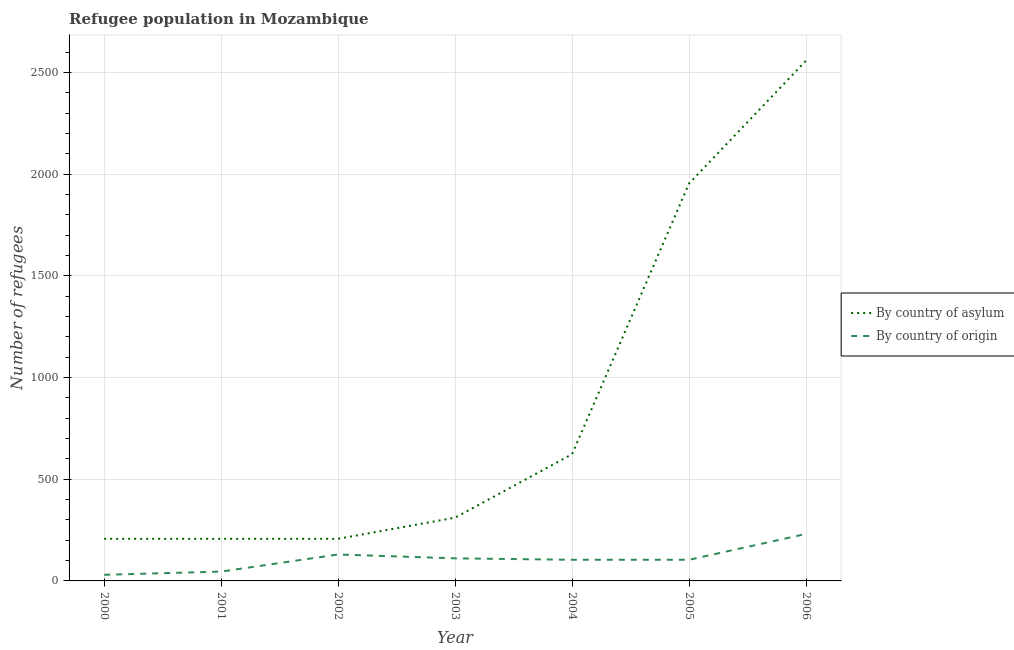How many different coloured lines are there?
Keep it short and to the point. 2. What is the number of refugees by country of asylum in 2005?
Your response must be concise. 1954. Across all years, what is the maximum number of refugees by country of asylum?
Provide a short and direct response. 2558. Across all years, what is the minimum number of refugees by country of asylum?
Make the answer very short. 207. What is the total number of refugees by country of origin in the graph?
Your answer should be compact. 756. What is the difference between the number of refugees by country of asylum in 2000 and that in 2006?
Your answer should be compact. -2351. What is the difference between the number of refugees by country of asylum in 2005 and the number of refugees by country of origin in 2002?
Your response must be concise. 1824. What is the average number of refugees by country of asylum per year?
Your response must be concise. 866.71. In the year 2002, what is the difference between the number of refugees by country of origin and number of refugees by country of asylum?
Offer a very short reply. -77. In how many years, is the number of refugees by country of origin greater than 1000?
Your answer should be compact. 0. What is the ratio of the number of refugees by country of origin in 2002 to that in 2006?
Provide a short and direct response. 0.56. Is the number of refugees by country of origin in 2002 less than that in 2004?
Provide a succinct answer. No. What is the difference between the highest and the second highest number of refugees by country of origin?
Make the answer very short. 101. What is the difference between the highest and the lowest number of refugees by country of asylum?
Offer a very short reply. 2351. Does the number of refugees by country of origin monotonically increase over the years?
Ensure brevity in your answer.  No. Is the number of refugees by country of origin strictly less than the number of refugees by country of asylum over the years?
Make the answer very short. Yes. How many lines are there?
Make the answer very short. 2. What is the difference between two consecutive major ticks on the Y-axis?
Your answer should be compact. 500. Where does the legend appear in the graph?
Provide a succinct answer. Center right. What is the title of the graph?
Give a very brief answer. Refugee population in Mozambique. What is the label or title of the X-axis?
Your response must be concise. Year. What is the label or title of the Y-axis?
Your answer should be very brief. Number of refugees. What is the Number of refugees of By country of asylum in 2000?
Offer a terse response. 207. What is the Number of refugees of By country of asylum in 2001?
Provide a succinct answer. 207. What is the Number of refugees in By country of asylum in 2002?
Ensure brevity in your answer.  207. What is the Number of refugees of By country of origin in 2002?
Provide a succinct answer. 130. What is the Number of refugees in By country of asylum in 2003?
Provide a short and direct response. 311. What is the Number of refugees in By country of origin in 2003?
Keep it short and to the point. 111. What is the Number of refugees in By country of asylum in 2004?
Make the answer very short. 623. What is the Number of refugees of By country of origin in 2004?
Offer a terse response. 104. What is the Number of refugees of By country of asylum in 2005?
Make the answer very short. 1954. What is the Number of refugees in By country of origin in 2005?
Provide a succinct answer. 104. What is the Number of refugees of By country of asylum in 2006?
Make the answer very short. 2558. What is the Number of refugees in By country of origin in 2006?
Keep it short and to the point. 231. Across all years, what is the maximum Number of refugees of By country of asylum?
Provide a short and direct response. 2558. Across all years, what is the maximum Number of refugees of By country of origin?
Make the answer very short. 231. Across all years, what is the minimum Number of refugees in By country of asylum?
Offer a terse response. 207. What is the total Number of refugees of By country of asylum in the graph?
Ensure brevity in your answer.  6067. What is the total Number of refugees in By country of origin in the graph?
Provide a short and direct response. 756. What is the difference between the Number of refugees in By country of origin in 2000 and that in 2001?
Give a very brief answer. -16. What is the difference between the Number of refugees of By country of asylum in 2000 and that in 2002?
Your answer should be compact. 0. What is the difference between the Number of refugees of By country of origin in 2000 and that in 2002?
Your answer should be compact. -100. What is the difference between the Number of refugees in By country of asylum in 2000 and that in 2003?
Your answer should be compact. -104. What is the difference between the Number of refugees in By country of origin in 2000 and that in 2003?
Your answer should be very brief. -81. What is the difference between the Number of refugees in By country of asylum in 2000 and that in 2004?
Provide a succinct answer. -416. What is the difference between the Number of refugees in By country of origin in 2000 and that in 2004?
Keep it short and to the point. -74. What is the difference between the Number of refugees in By country of asylum in 2000 and that in 2005?
Offer a terse response. -1747. What is the difference between the Number of refugees of By country of origin in 2000 and that in 2005?
Offer a terse response. -74. What is the difference between the Number of refugees of By country of asylum in 2000 and that in 2006?
Ensure brevity in your answer.  -2351. What is the difference between the Number of refugees in By country of origin in 2000 and that in 2006?
Ensure brevity in your answer.  -201. What is the difference between the Number of refugees of By country of origin in 2001 and that in 2002?
Offer a very short reply. -84. What is the difference between the Number of refugees of By country of asylum in 2001 and that in 2003?
Provide a short and direct response. -104. What is the difference between the Number of refugees in By country of origin in 2001 and that in 2003?
Provide a succinct answer. -65. What is the difference between the Number of refugees in By country of asylum in 2001 and that in 2004?
Your answer should be very brief. -416. What is the difference between the Number of refugees of By country of origin in 2001 and that in 2004?
Offer a very short reply. -58. What is the difference between the Number of refugees in By country of asylum in 2001 and that in 2005?
Ensure brevity in your answer.  -1747. What is the difference between the Number of refugees of By country of origin in 2001 and that in 2005?
Give a very brief answer. -58. What is the difference between the Number of refugees in By country of asylum in 2001 and that in 2006?
Your answer should be compact. -2351. What is the difference between the Number of refugees in By country of origin in 2001 and that in 2006?
Offer a terse response. -185. What is the difference between the Number of refugees in By country of asylum in 2002 and that in 2003?
Offer a very short reply. -104. What is the difference between the Number of refugees in By country of asylum in 2002 and that in 2004?
Ensure brevity in your answer.  -416. What is the difference between the Number of refugees in By country of asylum in 2002 and that in 2005?
Give a very brief answer. -1747. What is the difference between the Number of refugees in By country of origin in 2002 and that in 2005?
Your response must be concise. 26. What is the difference between the Number of refugees of By country of asylum in 2002 and that in 2006?
Provide a succinct answer. -2351. What is the difference between the Number of refugees of By country of origin in 2002 and that in 2006?
Ensure brevity in your answer.  -101. What is the difference between the Number of refugees of By country of asylum in 2003 and that in 2004?
Make the answer very short. -312. What is the difference between the Number of refugees of By country of origin in 2003 and that in 2004?
Your answer should be compact. 7. What is the difference between the Number of refugees of By country of asylum in 2003 and that in 2005?
Your answer should be compact. -1643. What is the difference between the Number of refugees of By country of origin in 2003 and that in 2005?
Make the answer very short. 7. What is the difference between the Number of refugees of By country of asylum in 2003 and that in 2006?
Offer a very short reply. -2247. What is the difference between the Number of refugees in By country of origin in 2003 and that in 2006?
Give a very brief answer. -120. What is the difference between the Number of refugees of By country of asylum in 2004 and that in 2005?
Provide a short and direct response. -1331. What is the difference between the Number of refugees of By country of origin in 2004 and that in 2005?
Ensure brevity in your answer.  0. What is the difference between the Number of refugees in By country of asylum in 2004 and that in 2006?
Make the answer very short. -1935. What is the difference between the Number of refugees of By country of origin in 2004 and that in 2006?
Your response must be concise. -127. What is the difference between the Number of refugees of By country of asylum in 2005 and that in 2006?
Provide a succinct answer. -604. What is the difference between the Number of refugees in By country of origin in 2005 and that in 2006?
Your answer should be very brief. -127. What is the difference between the Number of refugees in By country of asylum in 2000 and the Number of refugees in By country of origin in 2001?
Provide a short and direct response. 161. What is the difference between the Number of refugees of By country of asylum in 2000 and the Number of refugees of By country of origin in 2002?
Ensure brevity in your answer.  77. What is the difference between the Number of refugees of By country of asylum in 2000 and the Number of refugees of By country of origin in 2003?
Your response must be concise. 96. What is the difference between the Number of refugees of By country of asylum in 2000 and the Number of refugees of By country of origin in 2004?
Your answer should be very brief. 103. What is the difference between the Number of refugees in By country of asylum in 2000 and the Number of refugees in By country of origin in 2005?
Keep it short and to the point. 103. What is the difference between the Number of refugees in By country of asylum in 2000 and the Number of refugees in By country of origin in 2006?
Your response must be concise. -24. What is the difference between the Number of refugees in By country of asylum in 2001 and the Number of refugees in By country of origin in 2003?
Offer a terse response. 96. What is the difference between the Number of refugees in By country of asylum in 2001 and the Number of refugees in By country of origin in 2004?
Your answer should be compact. 103. What is the difference between the Number of refugees of By country of asylum in 2001 and the Number of refugees of By country of origin in 2005?
Provide a succinct answer. 103. What is the difference between the Number of refugees in By country of asylum in 2002 and the Number of refugees in By country of origin in 2003?
Your answer should be compact. 96. What is the difference between the Number of refugees of By country of asylum in 2002 and the Number of refugees of By country of origin in 2004?
Your answer should be very brief. 103. What is the difference between the Number of refugees of By country of asylum in 2002 and the Number of refugees of By country of origin in 2005?
Ensure brevity in your answer.  103. What is the difference between the Number of refugees of By country of asylum in 2003 and the Number of refugees of By country of origin in 2004?
Give a very brief answer. 207. What is the difference between the Number of refugees in By country of asylum in 2003 and the Number of refugees in By country of origin in 2005?
Give a very brief answer. 207. What is the difference between the Number of refugees of By country of asylum in 2003 and the Number of refugees of By country of origin in 2006?
Ensure brevity in your answer.  80. What is the difference between the Number of refugees in By country of asylum in 2004 and the Number of refugees in By country of origin in 2005?
Offer a very short reply. 519. What is the difference between the Number of refugees in By country of asylum in 2004 and the Number of refugees in By country of origin in 2006?
Give a very brief answer. 392. What is the difference between the Number of refugees of By country of asylum in 2005 and the Number of refugees of By country of origin in 2006?
Provide a short and direct response. 1723. What is the average Number of refugees of By country of asylum per year?
Make the answer very short. 866.71. What is the average Number of refugees of By country of origin per year?
Your response must be concise. 108. In the year 2000, what is the difference between the Number of refugees in By country of asylum and Number of refugees in By country of origin?
Give a very brief answer. 177. In the year 2001, what is the difference between the Number of refugees of By country of asylum and Number of refugees of By country of origin?
Your answer should be compact. 161. In the year 2002, what is the difference between the Number of refugees in By country of asylum and Number of refugees in By country of origin?
Offer a very short reply. 77. In the year 2003, what is the difference between the Number of refugees of By country of asylum and Number of refugees of By country of origin?
Keep it short and to the point. 200. In the year 2004, what is the difference between the Number of refugees in By country of asylum and Number of refugees in By country of origin?
Ensure brevity in your answer.  519. In the year 2005, what is the difference between the Number of refugees in By country of asylum and Number of refugees in By country of origin?
Offer a very short reply. 1850. In the year 2006, what is the difference between the Number of refugees in By country of asylum and Number of refugees in By country of origin?
Provide a succinct answer. 2327. What is the ratio of the Number of refugees of By country of asylum in 2000 to that in 2001?
Your answer should be very brief. 1. What is the ratio of the Number of refugees of By country of origin in 2000 to that in 2001?
Provide a succinct answer. 0.65. What is the ratio of the Number of refugees of By country of asylum in 2000 to that in 2002?
Offer a terse response. 1. What is the ratio of the Number of refugees of By country of origin in 2000 to that in 2002?
Provide a succinct answer. 0.23. What is the ratio of the Number of refugees in By country of asylum in 2000 to that in 2003?
Keep it short and to the point. 0.67. What is the ratio of the Number of refugees in By country of origin in 2000 to that in 2003?
Give a very brief answer. 0.27. What is the ratio of the Number of refugees in By country of asylum in 2000 to that in 2004?
Ensure brevity in your answer.  0.33. What is the ratio of the Number of refugees of By country of origin in 2000 to that in 2004?
Offer a very short reply. 0.29. What is the ratio of the Number of refugees in By country of asylum in 2000 to that in 2005?
Give a very brief answer. 0.11. What is the ratio of the Number of refugees in By country of origin in 2000 to that in 2005?
Make the answer very short. 0.29. What is the ratio of the Number of refugees of By country of asylum in 2000 to that in 2006?
Provide a succinct answer. 0.08. What is the ratio of the Number of refugees of By country of origin in 2000 to that in 2006?
Your answer should be very brief. 0.13. What is the ratio of the Number of refugees in By country of asylum in 2001 to that in 2002?
Offer a terse response. 1. What is the ratio of the Number of refugees in By country of origin in 2001 to that in 2002?
Your answer should be very brief. 0.35. What is the ratio of the Number of refugees in By country of asylum in 2001 to that in 2003?
Your answer should be compact. 0.67. What is the ratio of the Number of refugees in By country of origin in 2001 to that in 2003?
Offer a very short reply. 0.41. What is the ratio of the Number of refugees of By country of asylum in 2001 to that in 2004?
Keep it short and to the point. 0.33. What is the ratio of the Number of refugees in By country of origin in 2001 to that in 2004?
Ensure brevity in your answer.  0.44. What is the ratio of the Number of refugees of By country of asylum in 2001 to that in 2005?
Provide a succinct answer. 0.11. What is the ratio of the Number of refugees in By country of origin in 2001 to that in 2005?
Your answer should be compact. 0.44. What is the ratio of the Number of refugees in By country of asylum in 2001 to that in 2006?
Offer a terse response. 0.08. What is the ratio of the Number of refugees in By country of origin in 2001 to that in 2006?
Keep it short and to the point. 0.2. What is the ratio of the Number of refugees in By country of asylum in 2002 to that in 2003?
Provide a succinct answer. 0.67. What is the ratio of the Number of refugees of By country of origin in 2002 to that in 2003?
Your response must be concise. 1.17. What is the ratio of the Number of refugees in By country of asylum in 2002 to that in 2004?
Your answer should be very brief. 0.33. What is the ratio of the Number of refugees of By country of origin in 2002 to that in 2004?
Give a very brief answer. 1.25. What is the ratio of the Number of refugees of By country of asylum in 2002 to that in 2005?
Your response must be concise. 0.11. What is the ratio of the Number of refugees in By country of asylum in 2002 to that in 2006?
Make the answer very short. 0.08. What is the ratio of the Number of refugees of By country of origin in 2002 to that in 2006?
Your response must be concise. 0.56. What is the ratio of the Number of refugees in By country of asylum in 2003 to that in 2004?
Make the answer very short. 0.5. What is the ratio of the Number of refugees of By country of origin in 2003 to that in 2004?
Give a very brief answer. 1.07. What is the ratio of the Number of refugees in By country of asylum in 2003 to that in 2005?
Your response must be concise. 0.16. What is the ratio of the Number of refugees in By country of origin in 2003 to that in 2005?
Your answer should be very brief. 1.07. What is the ratio of the Number of refugees in By country of asylum in 2003 to that in 2006?
Give a very brief answer. 0.12. What is the ratio of the Number of refugees in By country of origin in 2003 to that in 2006?
Keep it short and to the point. 0.48. What is the ratio of the Number of refugees of By country of asylum in 2004 to that in 2005?
Your answer should be compact. 0.32. What is the ratio of the Number of refugees in By country of origin in 2004 to that in 2005?
Ensure brevity in your answer.  1. What is the ratio of the Number of refugees in By country of asylum in 2004 to that in 2006?
Keep it short and to the point. 0.24. What is the ratio of the Number of refugees of By country of origin in 2004 to that in 2006?
Offer a very short reply. 0.45. What is the ratio of the Number of refugees in By country of asylum in 2005 to that in 2006?
Keep it short and to the point. 0.76. What is the ratio of the Number of refugees in By country of origin in 2005 to that in 2006?
Give a very brief answer. 0.45. What is the difference between the highest and the second highest Number of refugees in By country of asylum?
Make the answer very short. 604. What is the difference between the highest and the second highest Number of refugees in By country of origin?
Make the answer very short. 101. What is the difference between the highest and the lowest Number of refugees in By country of asylum?
Keep it short and to the point. 2351. What is the difference between the highest and the lowest Number of refugees in By country of origin?
Provide a succinct answer. 201. 